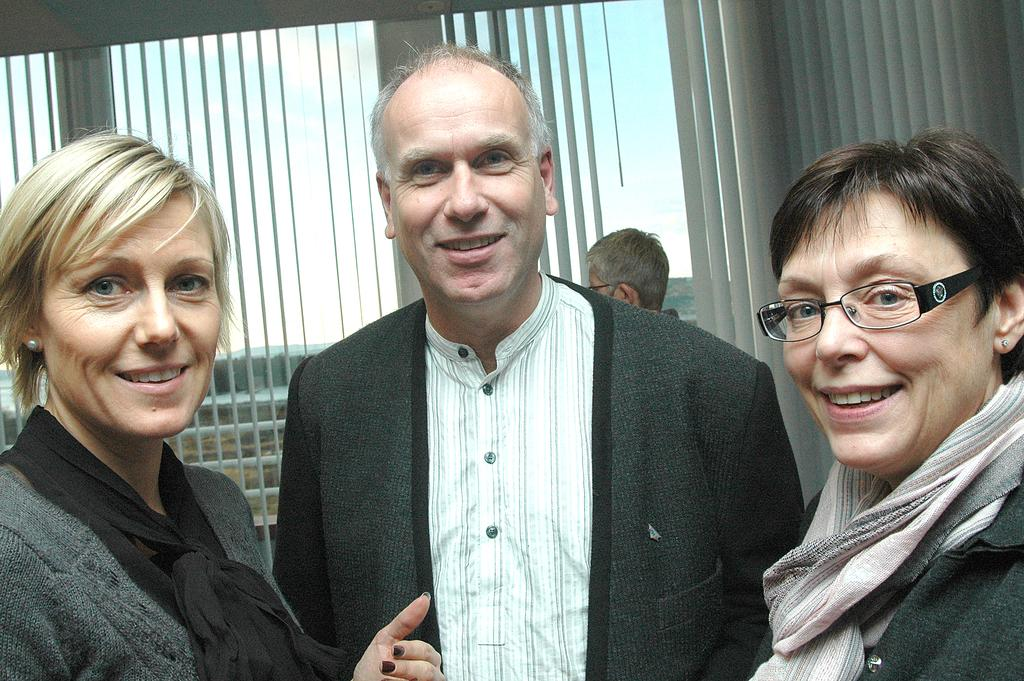How many people are in the image? There are three people in the image. What are the people doing in the image? The people are standing and looking and smiling at someone. What type of turkey can be seen washing its hands in the image? There is no turkey present in the image, and therefore no such activity can be observed. 